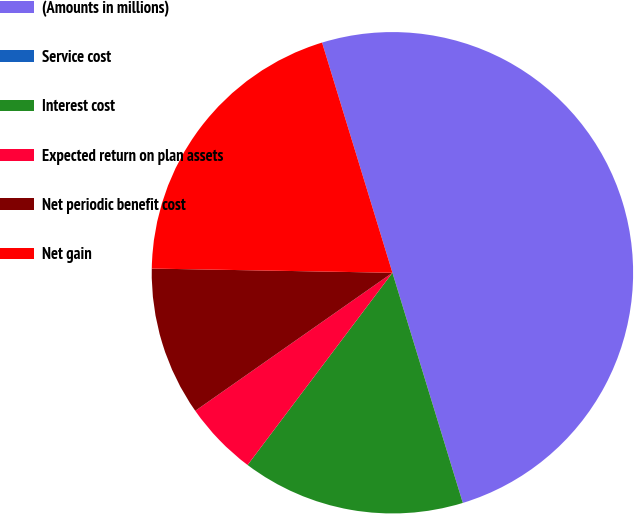<chart> <loc_0><loc_0><loc_500><loc_500><pie_chart><fcel>(Amounts in millions)<fcel>Service cost<fcel>Interest cost<fcel>Expected return on plan assets<fcel>Net periodic benefit cost<fcel>Net gain<nl><fcel>50.0%<fcel>0.0%<fcel>15.0%<fcel>5.0%<fcel>10.0%<fcel>20.0%<nl></chart> 